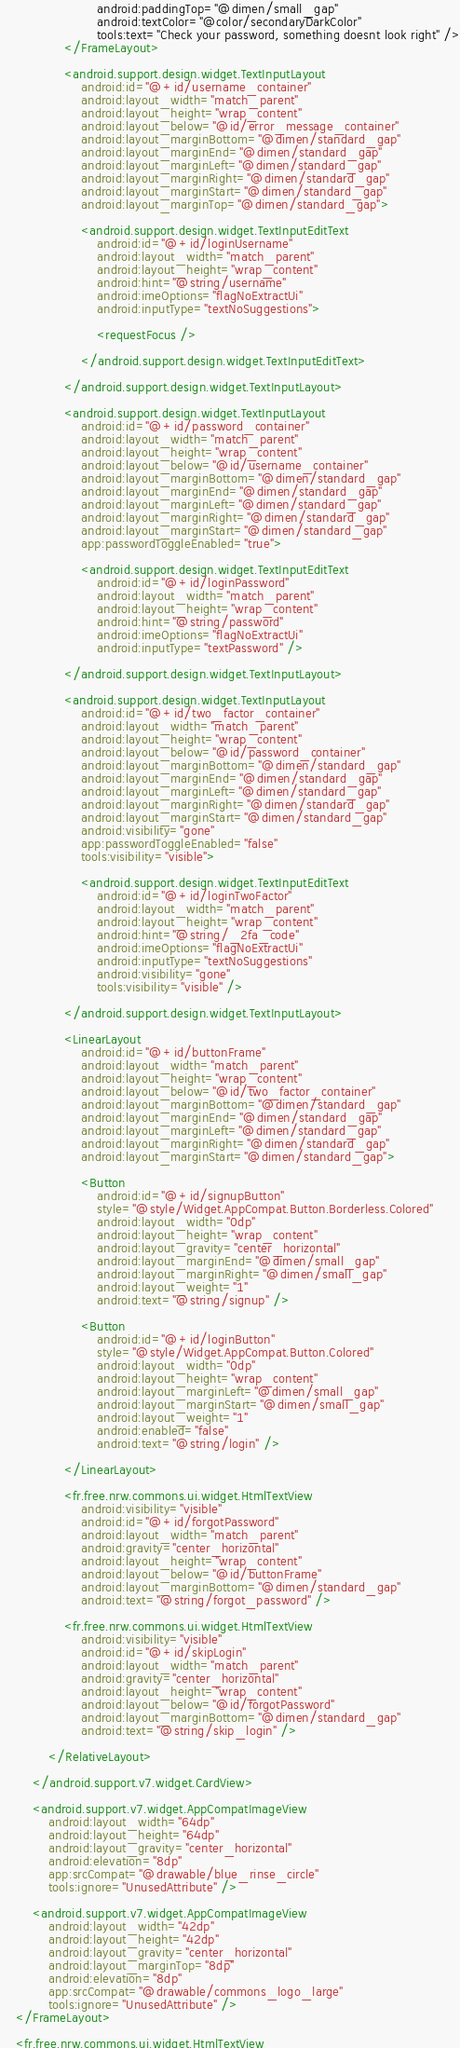<code> <loc_0><loc_0><loc_500><loc_500><_XML_>                        android:paddingTop="@dimen/small_gap"
                        android:textColor="@color/secondaryDarkColor"
                        tools:text="Check your password, something doesnt look right" />
                </FrameLayout>

                <android.support.design.widget.TextInputLayout
                    android:id="@+id/username_container"
                    android:layout_width="match_parent"
                    android:layout_height="wrap_content"
                    android:layout_below="@id/error_message_container"
                    android:layout_marginBottom="@dimen/standard_gap"
                    android:layout_marginEnd="@dimen/standard_gap"
                    android:layout_marginLeft="@dimen/standard_gap"
                    android:layout_marginRight="@dimen/standard_gap"
                    android:layout_marginStart="@dimen/standard_gap"
                    android:layout_marginTop="@dimen/standard_gap">

                    <android.support.design.widget.TextInputEditText
                        android:id="@+id/loginUsername"
                        android:layout_width="match_parent"
                        android:layout_height="wrap_content"
                        android:hint="@string/username"
                        android:imeOptions="flagNoExtractUi"
                        android:inputType="textNoSuggestions">

                        <requestFocus />

                    </android.support.design.widget.TextInputEditText>

                </android.support.design.widget.TextInputLayout>

                <android.support.design.widget.TextInputLayout
                    android:id="@+id/password_container"
                    android:layout_width="match_parent"
                    android:layout_height="wrap_content"
                    android:layout_below="@id/username_container"
                    android:layout_marginBottom="@dimen/standard_gap"
                    android:layout_marginEnd="@dimen/standard_gap"
                    android:layout_marginLeft="@dimen/standard_gap"
                    android:layout_marginRight="@dimen/standard_gap"
                    android:layout_marginStart="@dimen/standard_gap"
                    app:passwordToggleEnabled="true">

                    <android.support.design.widget.TextInputEditText
                        android:id="@+id/loginPassword"
                        android:layout_width="match_parent"
                        android:layout_height="wrap_content"
                        android:hint="@string/password"
                        android:imeOptions="flagNoExtractUi"
                        android:inputType="textPassword" />

                </android.support.design.widget.TextInputLayout>

                <android.support.design.widget.TextInputLayout
                    android:id="@+id/two_factor_container"
                    android:layout_width="match_parent"
                    android:layout_height="wrap_content"
                    android:layout_below="@id/password_container"
                    android:layout_marginBottom="@dimen/standard_gap"
                    android:layout_marginEnd="@dimen/standard_gap"
                    android:layout_marginLeft="@dimen/standard_gap"
                    android:layout_marginRight="@dimen/standard_gap"
                    android:layout_marginStart="@dimen/standard_gap"
                    android:visibility="gone"
                    app:passwordToggleEnabled="false"
                    tools:visibility="visible">

                    <android.support.design.widget.TextInputEditText
                        android:id="@+id/loginTwoFactor"
                        android:layout_width="match_parent"
                        android:layout_height="wrap_content"
                        android:hint="@string/_2fa_code"
                        android:imeOptions="flagNoExtractUi"
                        android:inputType="textNoSuggestions"
                        android:visibility="gone"
                        tools:visibility="visible" />

                </android.support.design.widget.TextInputLayout>

                <LinearLayout
                    android:id="@+id/buttonFrame"
                    android:layout_width="match_parent"
                    android:layout_height="wrap_content"
                    android:layout_below="@id/two_factor_container"
                    android:layout_marginBottom="@dimen/standard_gap"
                    android:layout_marginEnd="@dimen/standard_gap"
                    android:layout_marginLeft="@dimen/standard_gap"
                    android:layout_marginRight="@dimen/standard_gap"
                    android:layout_marginStart="@dimen/standard_gap">

                    <Button
                        android:id="@+id/signupButton"
                        style="@style/Widget.AppCompat.Button.Borderless.Colored"
                        android:layout_width="0dp"
                        android:layout_height="wrap_content"
                        android:layout_gravity="center_horizontal"
                        android:layout_marginEnd="@dimen/small_gap"
                        android:layout_marginRight="@dimen/small_gap"
                        android:layout_weight="1"
                        android:text="@string/signup" />

                    <Button
                        android:id="@+id/loginButton"
                        style="@style/Widget.AppCompat.Button.Colored"
                        android:layout_width="0dp"
                        android:layout_height="wrap_content"
                        android:layout_marginLeft="@dimen/small_gap"
                        android:layout_marginStart="@dimen/small_gap"
                        android:layout_weight="1"
                        android:enabled="false"
                        android:text="@string/login" />

                </LinearLayout>

                <fr.free.nrw.commons.ui.widget.HtmlTextView
                    android:visibility="visible"
                    android:id="@+id/forgotPassword"
                    android:layout_width="match_parent"
                    android:gravity="center_horizontal"
                    android:layout_height="wrap_content"
                    android:layout_below="@id/buttonFrame"
                    android:layout_marginBottom="@dimen/standard_gap"
                    android:text="@string/forgot_password" />

                <fr.free.nrw.commons.ui.widget.HtmlTextView
                    android:visibility="visible"
                    android:id="@+id/skipLogin"
                    android:layout_width="match_parent"
                    android:gravity="center_horizontal"
                    android:layout_height="wrap_content"
                    android:layout_below="@id/forgotPassword"
                    android:layout_marginBottom="@dimen/standard_gap"
                    android:text="@string/skip_login" />

            </RelativeLayout>

        </android.support.v7.widget.CardView>

        <android.support.v7.widget.AppCompatImageView
            android:layout_width="64dp"
            android:layout_height="64dp"
            android:layout_gravity="center_horizontal"
            android:elevation="8dp"
            app:srcCompat="@drawable/blue_rinse_circle"
            tools:ignore="UnusedAttribute" />

        <android.support.v7.widget.AppCompatImageView
            android:layout_width="42dp"
            android:layout_height="42dp"
            android:layout_gravity="center_horizontal"
            android:layout_marginTop="8dp"
            android:elevation="8dp"
            app:srcCompat="@drawable/commons_logo_large"
            tools:ignore="UnusedAttribute" />
    </FrameLayout>

    <fr.free.nrw.commons.ui.widget.HtmlTextView</code> 